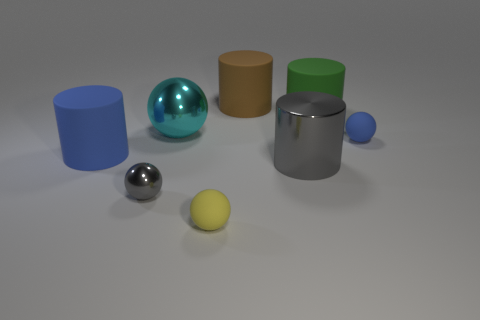There is a big object that is the same shape as the small shiny thing; what is its color?
Ensure brevity in your answer.  Cyan. What is the material of the gray cylinder that is the same size as the brown cylinder?
Your answer should be very brief. Metal. Is there a gray shiny thing of the same size as the cyan sphere?
Keep it short and to the point. Yes. There is a tiny rubber object to the right of the large gray cylinder; is it the same color as the small matte thing on the left side of the green matte object?
Keep it short and to the point. No. How many matte objects are large blue cylinders or green cylinders?
Give a very brief answer. 2. What number of brown matte cylinders are to the left of the blue cylinder that is left of the large matte thing that is right of the large gray cylinder?
Make the answer very short. 0. The green cylinder that is the same material as the tiny blue object is what size?
Your response must be concise. Large. What number of large things are the same color as the large shiny cylinder?
Your response must be concise. 0. Do the blue thing that is behind the blue cylinder and the big brown object have the same size?
Your answer should be compact. No. There is a matte thing that is behind the large gray metal cylinder and to the left of the brown thing; what is its color?
Ensure brevity in your answer.  Blue. 